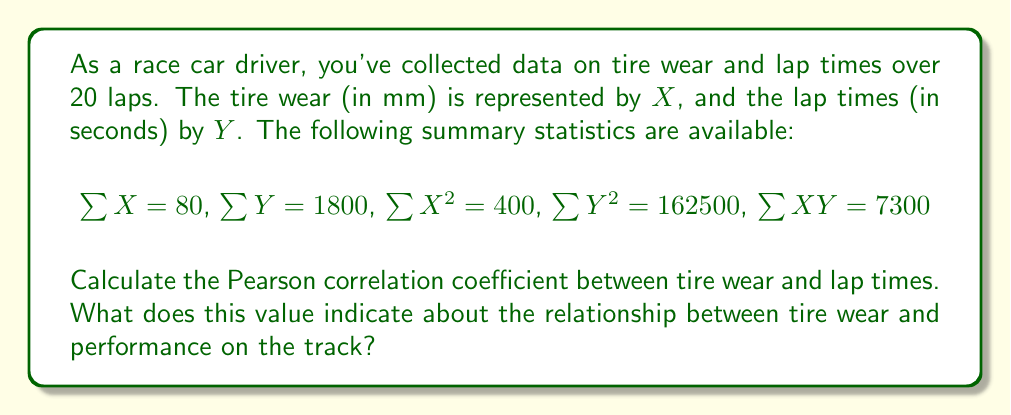Teach me how to tackle this problem. To calculate the Pearson correlation coefficient, we'll use the formula:

$$r = \frac{n\sum XY - \sum X \sum Y}{\sqrt{[n\sum X^2 - (\sum X)^2][n\sum Y^2 - (\sum Y)^2]}}$$

Where $n$ is the number of laps (20).

Step 1: Calculate $n\sum XY$
$20 \times 7300 = 146000$

Step 2: Calculate $\sum X \sum Y$
$80 \times 1800 = 144000$

Step 3: Calculate the numerator
$146000 - 144000 = 2000$

Step 4: Calculate $n\sum X^2$ and $(\sum X)^2$
$20 \times 400 = 8000$
$80^2 = 6400$

Step 5: Calculate $n\sum Y^2$ and $(\sum Y)^2$
$20 \times 162500 = 3250000$
$1800^2 = 3240000$

Step 6: Calculate the denominator
$\sqrt{(8000 - 6400)(3250000 - 3240000)} = \sqrt{1600 \times 10000} = 4000$

Step 7: Divide the numerator by the denominator
$r = \frac{2000}{4000} = 0.5$

The Pearson correlation coefficient is 0.5, indicating a moderate positive correlation between tire wear and lap times. This means that as tire wear increases, lap times tend to increase as well, suggesting a decrease in performance as tires degrade.
Answer: $r = 0.5$ 